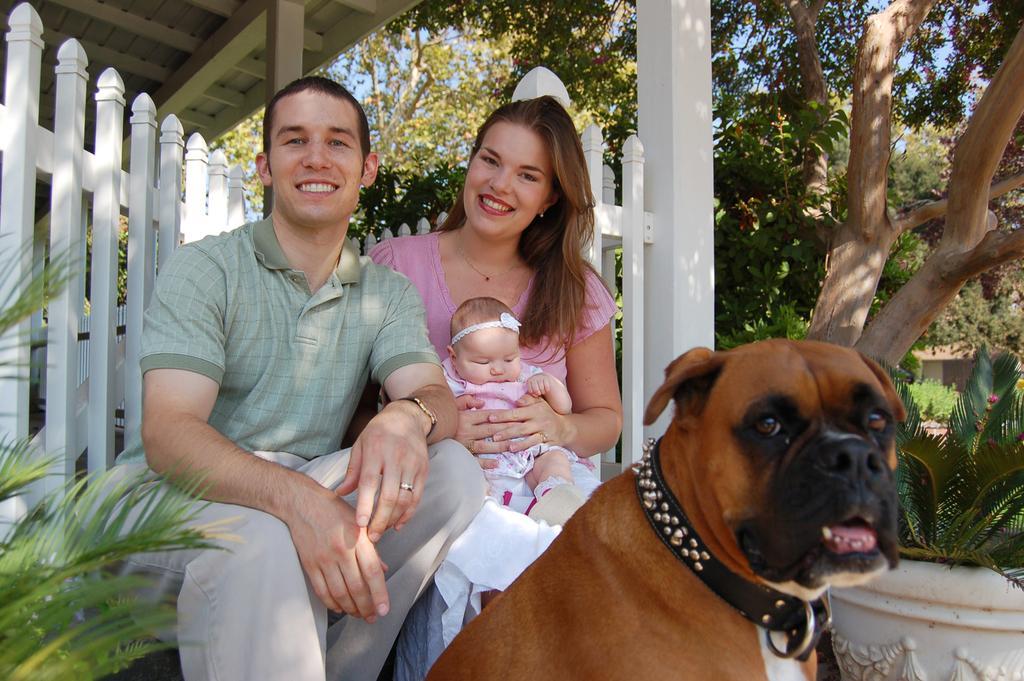In one or two sentences, can you explain what this image depicts? 2 people are sitting. The person at the left is wearing a green t shirt, the person at the right is wearing a pink t shirt and holding a baby. There is a brown dog in front of them. Behind them there is white fence. There are trees. 